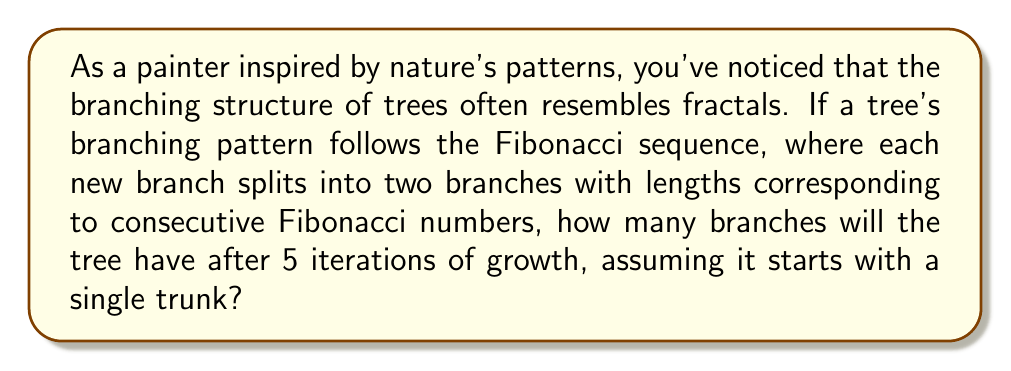Can you answer this question? Let's approach this step-by-step:

1) First, recall the Fibonacci sequence: 1, 1, 2, 3, 5, 8, 13, ...

2) In our tree model, each branch splits into two new branches. Let's count the branches at each iteration:

   Iteration 0 (initial trunk): 1 branch
   Iteration 1: 2 branches (the original splits into two)
   Iteration 2: 4 branches (each of the 2 branches splits)
   Iteration 3: 8 branches
   Iteration 4: 16 branches
   Iteration 5: 32 branches

3) We can see that the number of branches follows the sequence:

   $$1, 2, 4, 8, 16, 32, ...$$

4) This is a geometric sequence with a common ratio of 2. We can express this mathematically as:

   $$a_n = 2^n$$

   where $a_n$ is the number of branches after $n$ iterations.

5) For our question, we want $a_5$:

   $$a_5 = 2^5 = 32$$

6) It's worth noting that this branching pattern, while not directly following the Fibonacci sequence in terms of branch count, does relate to the Golden Ratio $\phi$, which is closely tied to the Fibonacci sequence. As the number of iterations approaches infinity, the ratio of branches at successive levels approaches 2, which is related to $\phi^2$.

7) This demonstrates how seemingly chaotic natural growth patterns can be described by simple mathematical rules, resulting in fractal-like structures.
Answer: 32 branches 